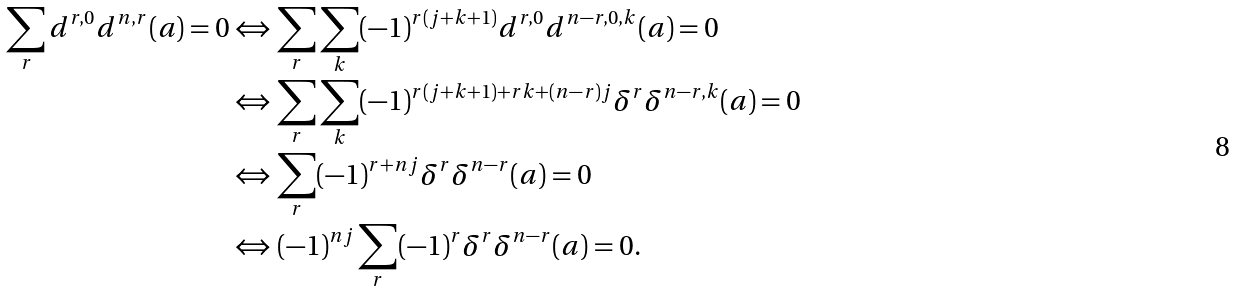Convert formula to latex. <formula><loc_0><loc_0><loc_500><loc_500>\sum _ { r } d ^ { r , 0 } d ^ { n , r } ( a ) = 0 & \Leftrightarrow \sum _ { r } \sum _ { k } ( - 1 ) ^ { r ( j + k + 1 ) } d ^ { r , 0 } d ^ { n - r , 0 , k } ( a ) = 0 \\ & \Leftrightarrow \sum _ { r } \sum _ { k } ( - 1 ) ^ { r ( j + k + 1 ) + r k + ( n - r ) j } \delta ^ { r } \delta ^ { n - r , k } ( a ) = 0 \\ & \Leftrightarrow \sum _ { r } ( - 1 ) ^ { r + n j } \delta ^ { r } \delta ^ { n - r } ( a ) = 0 \\ & \Leftrightarrow ( - 1 ) ^ { n j } \sum _ { r } ( - 1 ) ^ { r } \delta ^ { r } \delta ^ { n - r } ( a ) = 0 . \\</formula> 